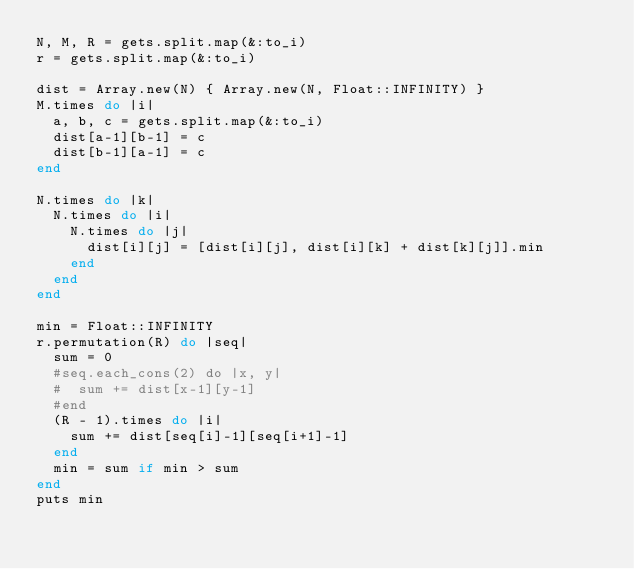Convert code to text. <code><loc_0><loc_0><loc_500><loc_500><_Ruby_>N, M, R = gets.split.map(&:to_i)
r = gets.split.map(&:to_i)

dist = Array.new(N) { Array.new(N, Float::INFINITY) }
M.times do |i|
  a, b, c = gets.split.map(&:to_i)
  dist[a-1][b-1] = c
  dist[b-1][a-1] = c
end

N.times do |k|
  N.times do |i|
    N.times do |j|
      dist[i][j] = [dist[i][j], dist[i][k] + dist[k][j]].min
    end
  end
end

min = Float::INFINITY
r.permutation(R) do |seq|
  sum = 0
  #seq.each_cons(2) do |x, y|
  #  sum += dist[x-1][y-1]
  #end
  (R - 1).times do |i|
    sum += dist[seq[i]-1][seq[i+1]-1]
  end
  min = sum if min > sum
end
puts min
</code> 